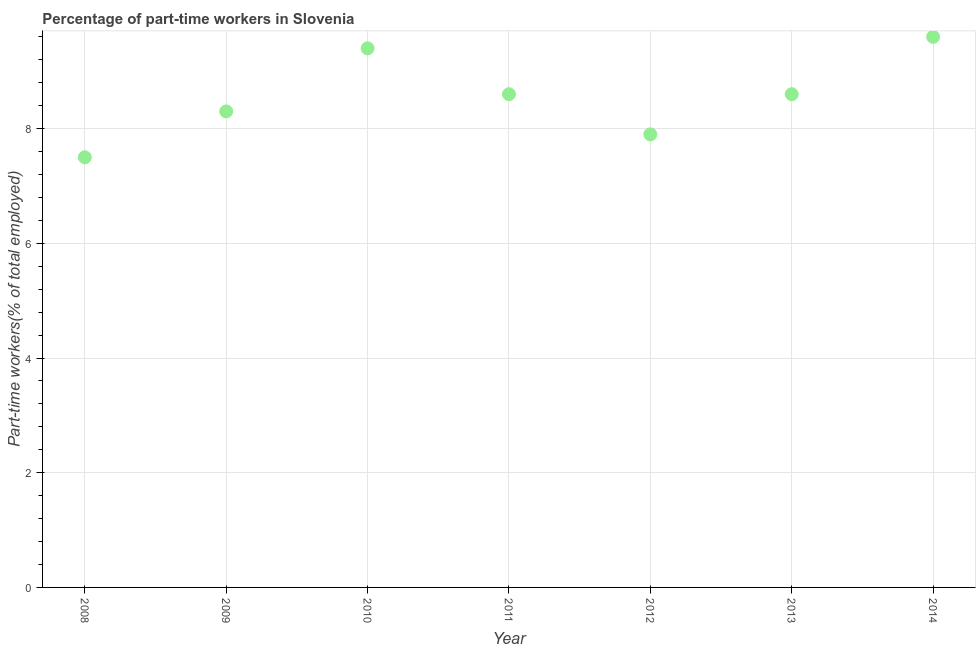What is the percentage of part-time workers in 2010?
Your answer should be very brief. 9.4. Across all years, what is the maximum percentage of part-time workers?
Offer a very short reply. 9.6. In which year was the percentage of part-time workers minimum?
Offer a terse response. 2008. What is the sum of the percentage of part-time workers?
Ensure brevity in your answer.  59.9. What is the difference between the percentage of part-time workers in 2010 and 2011?
Your response must be concise. 0.8. What is the average percentage of part-time workers per year?
Provide a succinct answer. 8.56. What is the median percentage of part-time workers?
Offer a terse response. 8.6. In how many years, is the percentage of part-time workers greater than 3.6 %?
Your answer should be very brief. 7. Do a majority of the years between 2012 and 2014 (inclusive) have percentage of part-time workers greater than 6 %?
Your answer should be compact. Yes. What is the ratio of the percentage of part-time workers in 2010 to that in 2014?
Your answer should be very brief. 0.98. Is the percentage of part-time workers in 2008 less than that in 2010?
Give a very brief answer. Yes. What is the difference between the highest and the second highest percentage of part-time workers?
Your answer should be compact. 0.2. Is the sum of the percentage of part-time workers in 2010 and 2014 greater than the maximum percentage of part-time workers across all years?
Ensure brevity in your answer.  Yes. What is the difference between the highest and the lowest percentage of part-time workers?
Provide a succinct answer. 2.1. How many dotlines are there?
Ensure brevity in your answer.  1. Are the values on the major ticks of Y-axis written in scientific E-notation?
Make the answer very short. No. What is the title of the graph?
Provide a succinct answer. Percentage of part-time workers in Slovenia. What is the label or title of the X-axis?
Provide a succinct answer. Year. What is the label or title of the Y-axis?
Provide a short and direct response. Part-time workers(% of total employed). What is the Part-time workers(% of total employed) in 2009?
Your answer should be compact. 8.3. What is the Part-time workers(% of total employed) in 2010?
Offer a very short reply. 9.4. What is the Part-time workers(% of total employed) in 2011?
Offer a very short reply. 8.6. What is the Part-time workers(% of total employed) in 2012?
Ensure brevity in your answer.  7.9. What is the Part-time workers(% of total employed) in 2013?
Ensure brevity in your answer.  8.6. What is the Part-time workers(% of total employed) in 2014?
Offer a terse response. 9.6. What is the difference between the Part-time workers(% of total employed) in 2008 and 2010?
Offer a terse response. -1.9. What is the difference between the Part-time workers(% of total employed) in 2008 and 2013?
Keep it short and to the point. -1.1. What is the difference between the Part-time workers(% of total employed) in 2008 and 2014?
Give a very brief answer. -2.1. What is the difference between the Part-time workers(% of total employed) in 2009 and 2014?
Keep it short and to the point. -1.3. What is the difference between the Part-time workers(% of total employed) in 2011 and 2013?
Ensure brevity in your answer.  0. What is the difference between the Part-time workers(% of total employed) in 2012 and 2014?
Ensure brevity in your answer.  -1.7. What is the ratio of the Part-time workers(% of total employed) in 2008 to that in 2009?
Give a very brief answer. 0.9. What is the ratio of the Part-time workers(% of total employed) in 2008 to that in 2010?
Make the answer very short. 0.8. What is the ratio of the Part-time workers(% of total employed) in 2008 to that in 2011?
Offer a very short reply. 0.87. What is the ratio of the Part-time workers(% of total employed) in 2008 to that in 2012?
Offer a terse response. 0.95. What is the ratio of the Part-time workers(% of total employed) in 2008 to that in 2013?
Provide a short and direct response. 0.87. What is the ratio of the Part-time workers(% of total employed) in 2008 to that in 2014?
Offer a terse response. 0.78. What is the ratio of the Part-time workers(% of total employed) in 2009 to that in 2010?
Your answer should be very brief. 0.88. What is the ratio of the Part-time workers(% of total employed) in 2009 to that in 2012?
Provide a succinct answer. 1.05. What is the ratio of the Part-time workers(% of total employed) in 2009 to that in 2013?
Provide a succinct answer. 0.96. What is the ratio of the Part-time workers(% of total employed) in 2009 to that in 2014?
Ensure brevity in your answer.  0.86. What is the ratio of the Part-time workers(% of total employed) in 2010 to that in 2011?
Your response must be concise. 1.09. What is the ratio of the Part-time workers(% of total employed) in 2010 to that in 2012?
Offer a terse response. 1.19. What is the ratio of the Part-time workers(% of total employed) in 2010 to that in 2013?
Make the answer very short. 1.09. What is the ratio of the Part-time workers(% of total employed) in 2011 to that in 2012?
Offer a very short reply. 1.09. What is the ratio of the Part-time workers(% of total employed) in 2011 to that in 2014?
Ensure brevity in your answer.  0.9. What is the ratio of the Part-time workers(% of total employed) in 2012 to that in 2013?
Provide a succinct answer. 0.92. What is the ratio of the Part-time workers(% of total employed) in 2012 to that in 2014?
Offer a terse response. 0.82. What is the ratio of the Part-time workers(% of total employed) in 2013 to that in 2014?
Ensure brevity in your answer.  0.9. 